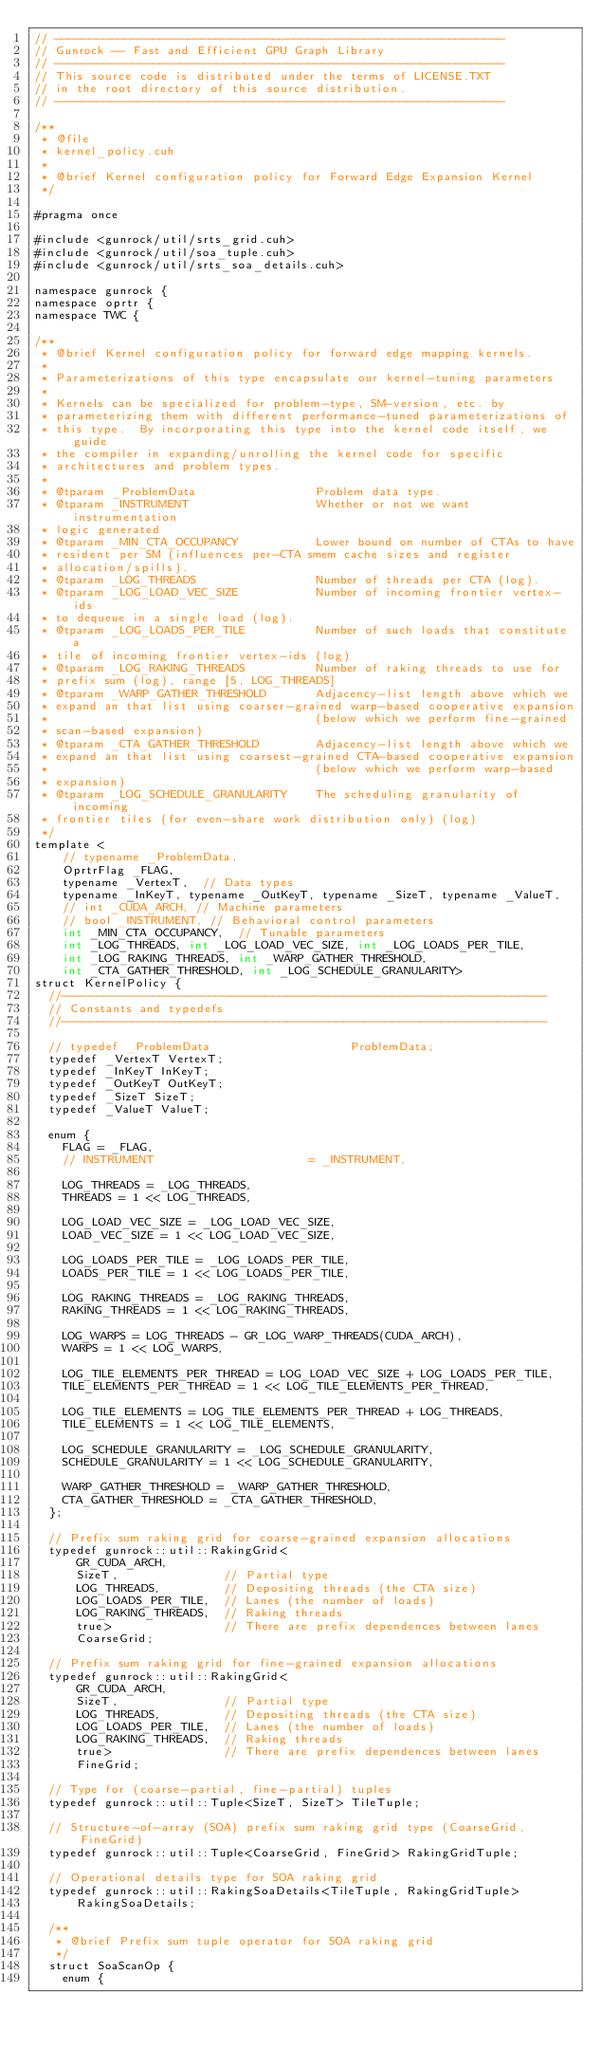<code> <loc_0><loc_0><loc_500><loc_500><_Cuda_>// ----------------------------------------------------------------
// Gunrock -- Fast and Efficient GPU Graph Library
// ----------------------------------------------------------------
// This source code is distributed under the terms of LICENSE.TXT
// in the root directory of this source distribution.
// ----------------------------------------------------------------

/**
 * @file
 * kernel_policy.cuh
 *
 * @brief Kernel configuration policy for Forward Edge Expansion Kernel
 */

#pragma once

#include <gunrock/util/srts_grid.cuh>
#include <gunrock/util/soa_tuple.cuh>
#include <gunrock/util/srts_soa_details.cuh>

namespace gunrock {
namespace oprtr {
namespace TWC {

/**
 * @brief Kernel configuration policy for forward edge mapping kernels.
 *
 * Parameterizations of this type encapsulate our kernel-tuning parameters
 *
 * Kernels can be specialized for problem-type, SM-version, etc. by
 * parameterizing them with different performance-tuned parameterizations of
 * this type.  By incorporating this type into the kernel code itself, we guide
 * the compiler in expanding/unrolling the kernel code for specific
 * architectures and problem types.
 *
 * @tparam _ProblemData                 Problem data type.
 * @tparam _INSTRUMENT                  Whether or not we want instrumentation
 * logic generated
 * @tparam _MIN_CTA_OCCUPANCY           Lower bound on number of CTAs to have
 * resident per SM (influences per-CTA smem cache sizes and register
 * allocation/spills).
 * @tparam _LOG_THREADS                 Number of threads per CTA (log).
 * @tparam _LOG_LOAD_VEC_SIZE           Number of incoming frontier vertex-ids
 * to dequeue in a single load (log).
 * @tparam _LOG_LOADS_PER_TILE          Number of such loads that constitute a
 * tile of incoming frontier vertex-ids (log)
 * @tparam _LOG_RAKING_THREADS          Number of raking threads to use for
 * prefix sum (log), range [5, LOG_THREADS]
 * @tparam _WARP_GATHER_THRESHOLD       Adjacency-list length above which we
 * expand an that list using coarser-grained warp-based cooperative expansion
 *                                      (below which we perform fine-grained
 * scan-based expansion)
 * @tparam _CTA_GATHER_THRESHOLD        Adjacency-list length above which we
 * expand an that list using coarsest-grained CTA-based cooperative expansion
 *                                      (below which we perform warp-based
 * expansion)
 * @tparam _LOG_SCHEDULE_GRANULARITY    The scheduling granularity of incoming
 * frontier tiles (for even-share work distribution only) (log)
 */
template <
    // typename _ProblemData,
    OprtrFlag _FLAG,
    typename _VertexT,  // Data types
    typename _InKeyT, typename _OutKeyT, typename _SizeT, typename _ValueT,
    // int _CUDA_ARCH, // Machine parameters
    // bool _INSTRUMENT, // Behavioral control parameters
    int _MIN_CTA_OCCUPANCY,  // Tunable parameters
    int _LOG_THREADS, int _LOG_LOAD_VEC_SIZE, int _LOG_LOADS_PER_TILE,
    int _LOG_RAKING_THREADS, int _WARP_GATHER_THRESHOLD,
    int _CTA_GATHER_THRESHOLD, int _LOG_SCHEDULE_GRANULARITY>
struct KernelPolicy {
  //---------------------------------------------------------------------
  // Constants and typedefs
  //---------------------------------------------------------------------

  // typedef _ProblemData                    ProblemData;
  typedef _VertexT VertexT;
  typedef _InKeyT InKeyT;
  typedef _OutKeyT OutKeyT;
  typedef _SizeT SizeT;
  typedef _ValueT ValueT;

  enum {
    FLAG = _FLAG,
    // INSTRUMENT                      = _INSTRUMENT,

    LOG_THREADS = _LOG_THREADS,
    THREADS = 1 << LOG_THREADS,

    LOG_LOAD_VEC_SIZE = _LOG_LOAD_VEC_SIZE,
    LOAD_VEC_SIZE = 1 << LOG_LOAD_VEC_SIZE,

    LOG_LOADS_PER_TILE = _LOG_LOADS_PER_TILE,
    LOADS_PER_TILE = 1 << LOG_LOADS_PER_TILE,

    LOG_RAKING_THREADS = _LOG_RAKING_THREADS,
    RAKING_THREADS = 1 << LOG_RAKING_THREADS,

    LOG_WARPS = LOG_THREADS - GR_LOG_WARP_THREADS(CUDA_ARCH),
    WARPS = 1 << LOG_WARPS,

    LOG_TILE_ELEMENTS_PER_THREAD = LOG_LOAD_VEC_SIZE + LOG_LOADS_PER_TILE,
    TILE_ELEMENTS_PER_THREAD = 1 << LOG_TILE_ELEMENTS_PER_THREAD,

    LOG_TILE_ELEMENTS = LOG_TILE_ELEMENTS_PER_THREAD + LOG_THREADS,
    TILE_ELEMENTS = 1 << LOG_TILE_ELEMENTS,

    LOG_SCHEDULE_GRANULARITY = _LOG_SCHEDULE_GRANULARITY,
    SCHEDULE_GRANULARITY = 1 << LOG_SCHEDULE_GRANULARITY,

    WARP_GATHER_THRESHOLD = _WARP_GATHER_THRESHOLD,
    CTA_GATHER_THRESHOLD = _CTA_GATHER_THRESHOLD,
  };

  // Prefix sum raking grid for coarse-grained expansion allocations
  typedef gunrock::util::RakingGrid<
      GR_CUDA_ARCH,
      SizeT,               // Partial type
      LOG_THREADS,         // Depositing threads (the CTA size)
      LOG_LOADS_PER_TILE,  // Lanes (the number of loads)
      LOG_RAKING_THREADS,  // Raking threads
      true>                // There are prefix dependences between lanes
      CoarseGrid;

  // Prefix sum raking grid for fine-grained expansion allocations
  typedef gunrock::util::RakingGrid<
      GR_CUDA_ARCH,
      SizeT,               // Partial type
      LOG_THREADS,         // Depositing threads (the CTA size)
      LOG_LOADS_PER_TILE,  // Lanes (the number of loads)
      LOG_RAKING_THREADS,  // Raking threads
      true>                // There are prefix dependences between lanes
      FineGrid;

  // Type for (coarse-partial, fine-partial) tuples
  typedef gunrock::util::Tuple<SizeT, SizeT> TileTuple;

  // Structure-of-array (SOA) prefix sum raking grid type (CoarseGrid, FineGrid)
  typedef gunrock::util::Tuple<CoarseGrid, FineGrid> RakingGridTuple;

  // Operational details type for SOA raking grid
  typedef gunrock::util::RakingSoaDetails<TileTuple, RakingGridTuple>
      RakingSoaDetails;

  /**
   * @brief Prefix sum tuple operator for SOA raking grid
   */
  struct SoaScanOp {
    enum {</code> 